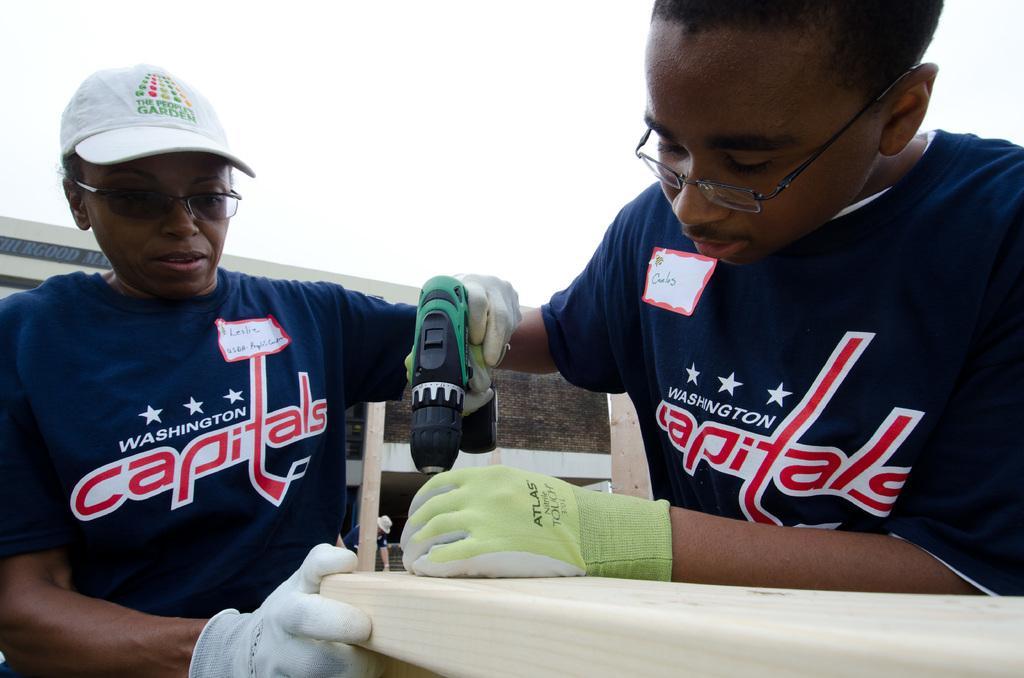Describe this image in one or two sentences. Here I can see two persons wearing blue color t-shirts, holding a machine in the hands and looking at the downwards. At the bottom there is a table. At the top, I can see the sky. 